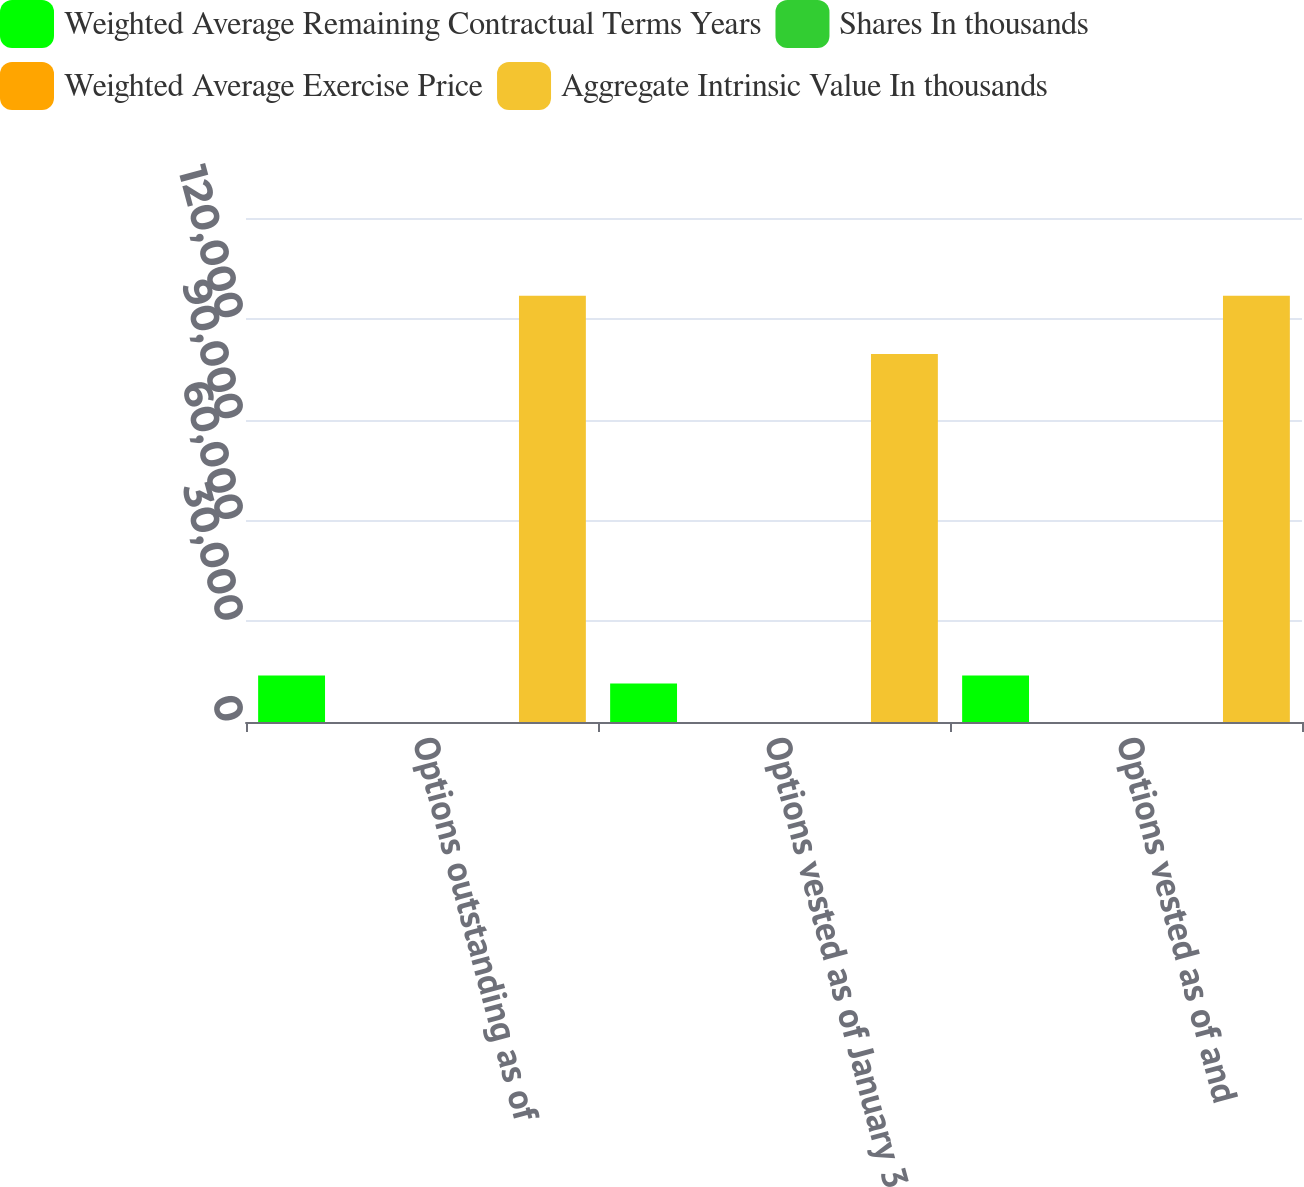Convert chart. <chart><loc_0><loc_0><loc_500><loc_500><stacked_bar_chart><ecel><fcel>Options outstanding as of<fcel>Options vested as of January 3<fcel>Options vested as of and<nl><fcel>Weighted Average Remaining Contractual Terms Years<fcel>13876<fcel>11425<fcel>13870<nl><fcel>Shares In thousands<fcel>9.71<fcel>9.28<fcel>9.71<nl><fcel>Weighted Average Exercise Price<fcel>3.3<fcel>2.8<fcel>3.3<nl><fcel>Aggregate Intrinsic Value In thousands<fcel>126892<fcel>109501<fcel>126866<nl></chart> 